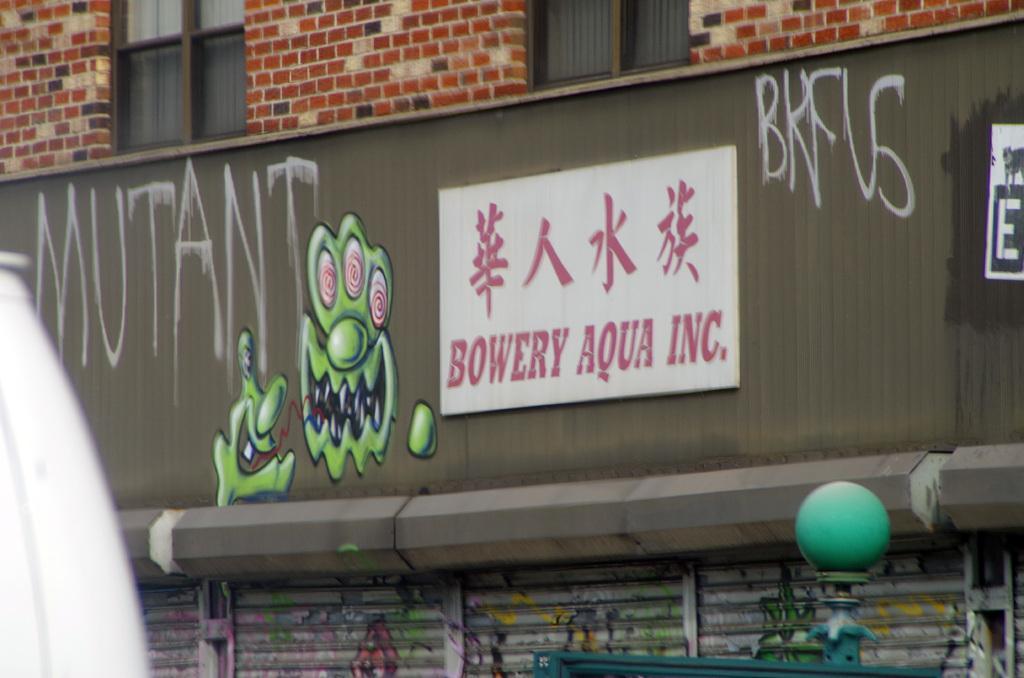How would you summarize this image in a sentence or two? In this picture we can see a wall and two windows, there is a board in the middle, we can see some text on the board, at the bottom we can see shutter. 